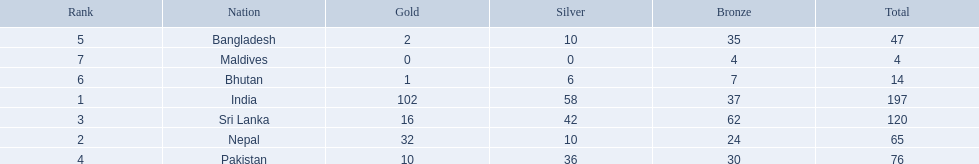What are the nations? India, Nepal, Sri Lanka, Pakistan, Bangladesh, Bhutan, Maldives. Parse the full table. {'header': ['Rank', 'Nation', 'Gold', 'Silver', 'Bronze', 'Total'], 'rows': [['5', 'Bangladesh', '2', '10', '35', '47'], ['7', 'Maldives', '0', '0', '4', '4'], ['6', 'Bhutan', '1', '6', '7', '14'], ['1', 'India', '102', '58', '37', '197'], ['3', 'Sri Lanka', '16', '42', '62', '120'], ['2', 'Nepal', '32', '10', '24', '65'], ['4', 'Pakistan', '10', '36', '30', '76']]} Of these, which one has earned the least amount of gold medals? Maldives. 